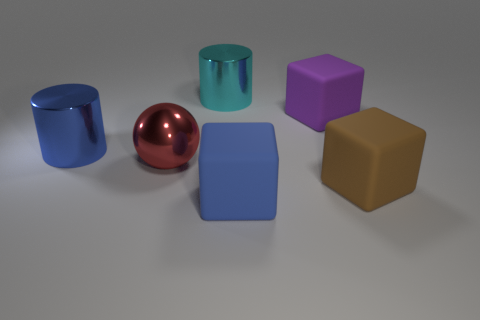Subtract all purple rubber cubes. How many cubes are left? 2 Add 3 green matte balls. How many objects exist? 9 Subtract all large cyan metallic things. Subtract all cyan metal things. How many objects are left? 4 Add 4 large shiny objects. How many large shiny objects are left? 7 Add 3 blue metallic cylinders. How many blue metallic cylinders exist? 4 Subtract 0 gray cylinders. How many objects are left? 6 Subtract all cylinders. How many objects are left? 4 